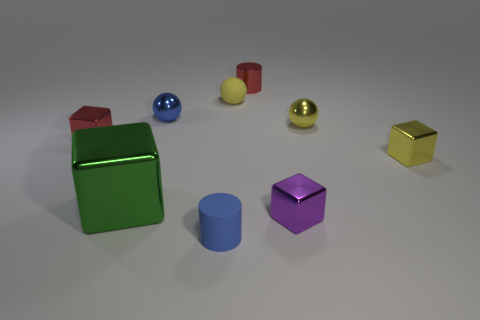Add 1 gray rubber cubes. How many objects exist? 10 Subtract all balls. How many objects are left? 6 Subtract 0 brown cubes. How many objects are left? 9 Subtract all small matte objects. Subtract all shiny spheres. How many objects are left? 5 Add 1 tiny red metal blocks. How many tiny red metal blocks are left? 2 Add 6 small yellow rubber things. How many small yellow rubber things exist? 7 